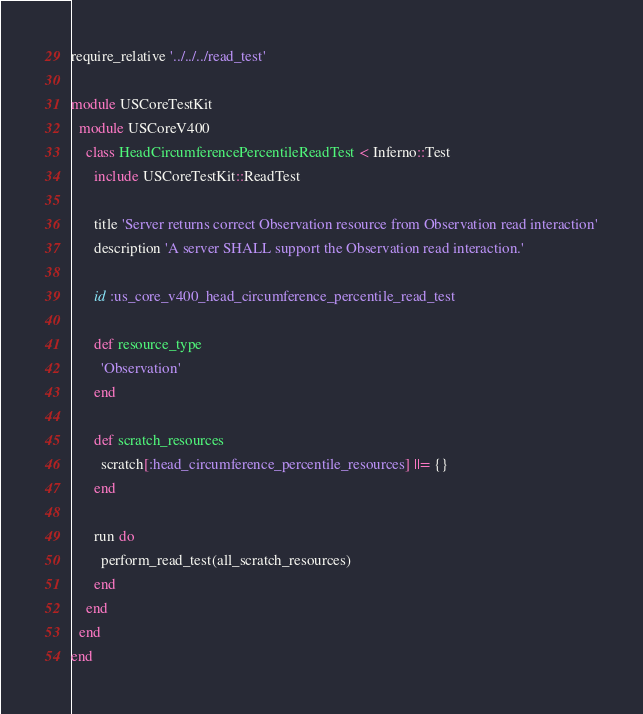Convert code to text. <code><loc_0><loc_0><loc_500><loc_500><_Ruby_>require_relative '../../../read_test'

module USCoreTestKit
  module USCoreV400
    class HeadCircumferencePercentileReadTest < Inferno::Test
      include USCoreTestKit::ReadTest

      title 'Server returns correct Observation resource from Observation read interaction'
      description 'A server SHALL support the Observation read interaction.'

      id :us_core_v400_head_circumference_percentile_read_test

      def resource_type
        'Observation'
      end

      def scratch_resources
        scratch[:head_circumference_percentile_resources] ||= {}
      end

      run do
        perform_read_test(all_scratch_resources)
      end
    end
  end
end
</code> 